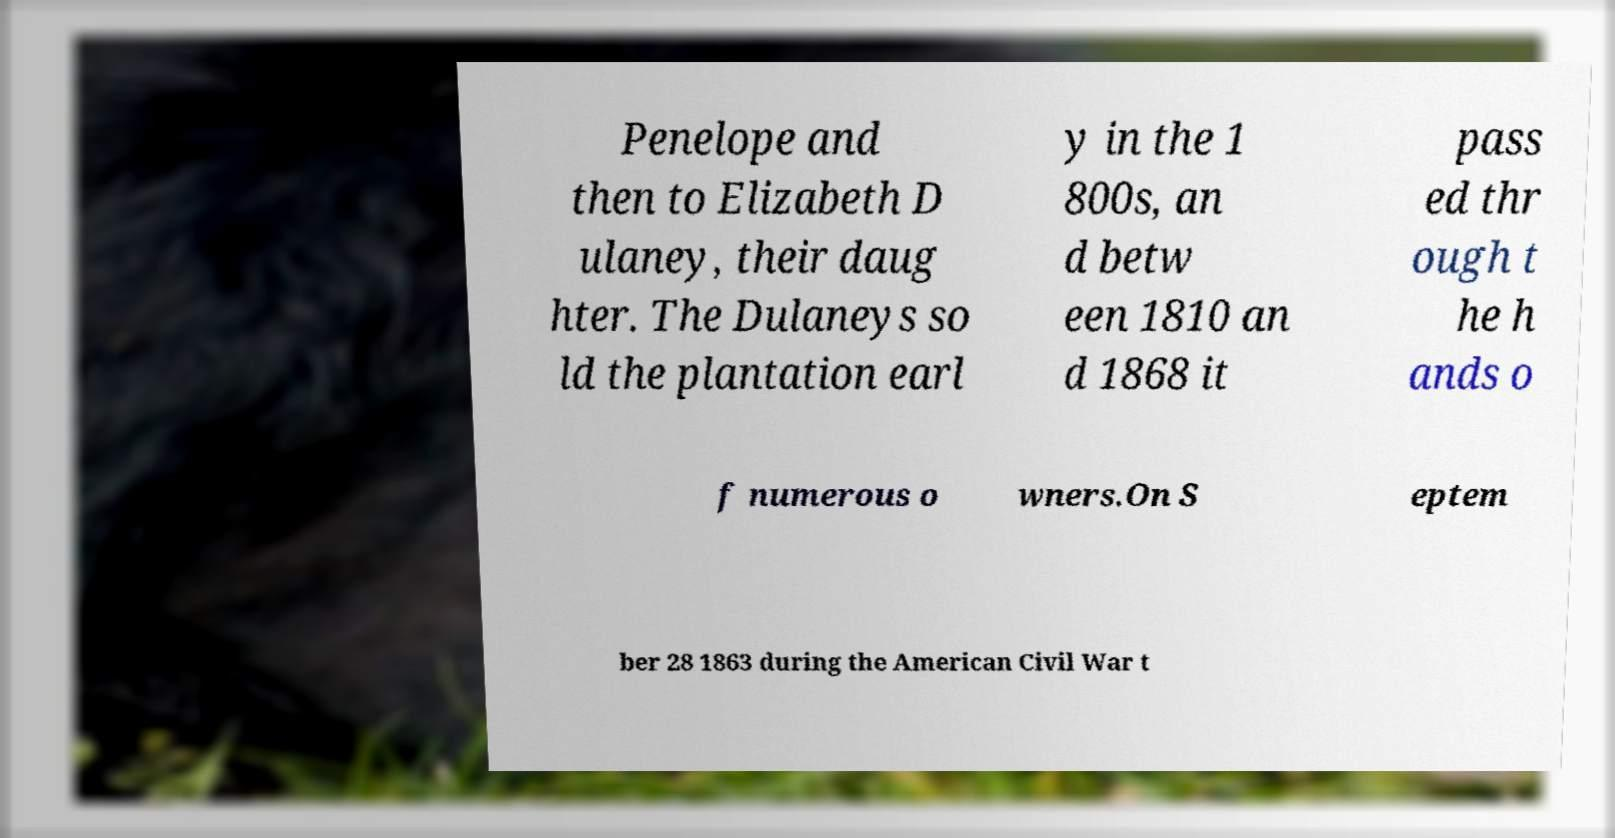For documentation purposes, I need the text within this image transcribed. Could you provide that? Penelope and then to Elizabeth D ulaney, their daug hter. The Dulaneys so ld the plantation earl y in the 1 800s, an d betw een 1810 an d 1868 it pass ed thr ough t he h ands o f numerous o wners.On S eptem ber 28 1863 during the American Civil War t 